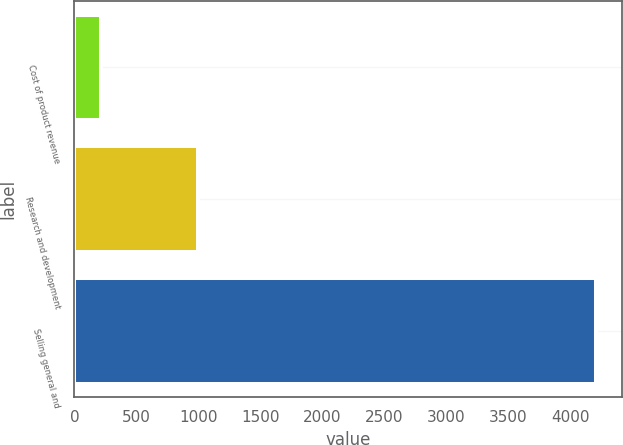Convert chart. <chart><loc_0><loc_0><loc_500><loc_500><bar_chart><fcel>Cost of product revenue<fcel>Research and development<fcel>Selling general and<nl><fcel>214<fcel>1001<fcel>4206<nl></chart> 